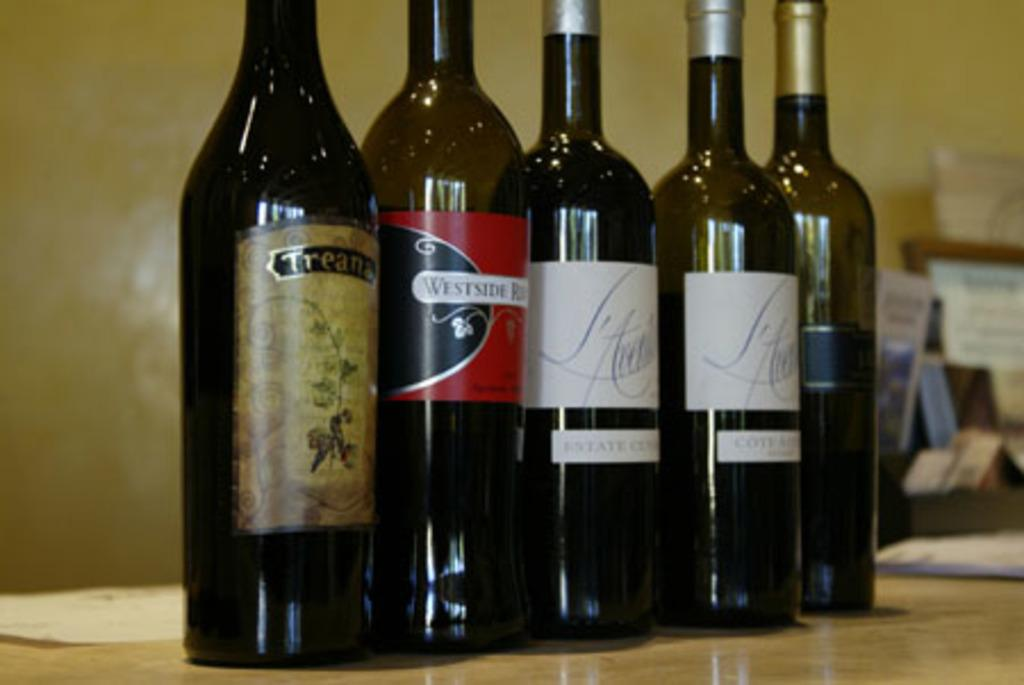<image>
Offer a succinct explanation of the picture presented. Five bottles of alcohol with different labels, one being Treana are sitting next to each other. 